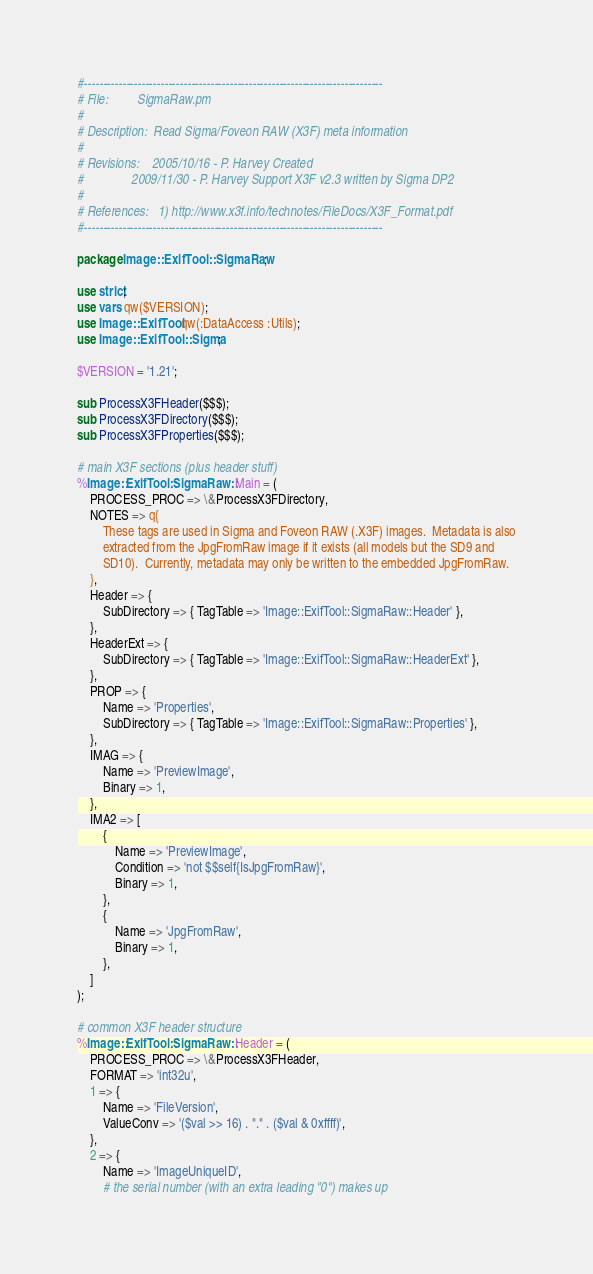<code> <loc_0><loc_0><loc_500><loc_500><_Perl_>#------------------------------------------------------------------------------
# File:         SigmaRaw.pm
#
# Description:  Read Sigma/Foveon RAW (X3F) meta information
#
# Revisions:    2005/10/16 - P. Harvey Created
#               2009/11/30 - P. Harvey Support X3F v2.3 written by Sigma DP2
#
# References:   1) http://www.x3f.info/technotes/FileDocs/X3F_Format.pdf
#------------------------------------------------------------------------------

package Image::ExifTool::SigmaRaw;

use strict;
use vars qw($VERSION);
use Image::ExifTool qw(:DataAccess :Utils);
use Image::ExifTool::Sigma;

$VERSION = '1.21';

sub ProcessX3FHeader($$$);
sub ProcessX3FDirectory($$$);
sub ProcessX3FProperties($$$);

# main X3F sections (plus header stuff)
%Image::ExifTool::SigmaRaw::Main = (
    PROCESS_PROC => \&ProcessX3FDirectory,
    NOTES => q{
        These tags are used in Sigma and Foveon RAW (.X3F) images.  Metadata is also
        extracted from the JpgFromRaw image if it exists (all models but the SD9 and
        SD10).  Currently, metadata may only be written to the embedded JpgFromRaw.
    },
    Header => {
        SubDirectory => { TagTable => 'Image::ExifTool::SigmaRaw::Header' },
    },
    HeaderExt => {
        SubDirectory => { TagTable => 'Image::ExifTool::SigmaRaw::HeaderExt' },
    },
    PROP => {
        Name => 'Properties',
        SubDirectory => { TagTable => 'Image::ExifTool::SigmaRaw::Properties' },
    },
    IMAG => {
        Name => 'PreviewImage',
        Binary => 1,
    },
    IMA2 => [
        {
            Name => 'PreviewImage',
            Condition => 'not $$self{IsJpgFromRaw}',
            Binary => 1,
        },
        {
            Name => 'JpgFromRaw',
            Binary => 1,
        },
    ]
);

# common X3F header structure
%Image::ExifTool::SigmaRaw::Header = (
    PROCESS_PROC => \&ProcessX3FHeader,
    FORMAT => 'int32u',
    1 => {
        Name => 'FileVersion',
        ValueConv => '($val >> 16) . "." . ($val & 0xffff)',
    },
    2 => {
        Name => 'ImageUniqueID',
        # the serial number (with an extra leading "0") makes up</code> 